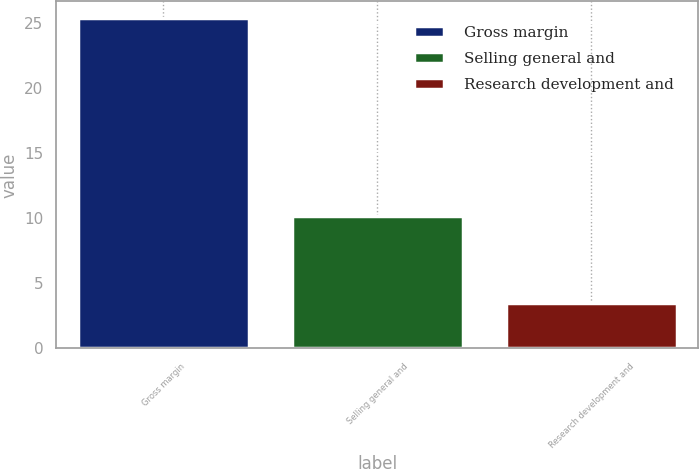Convert chart. <chart><loc_0><loc_0><loc_500><loc_500><bar_chart><fcel>Gross margin<fcel>Selling general and<fcel>Research development and<nl><fcel>25.4<fcel>10.2<fcel>3.5<nl></chart> 